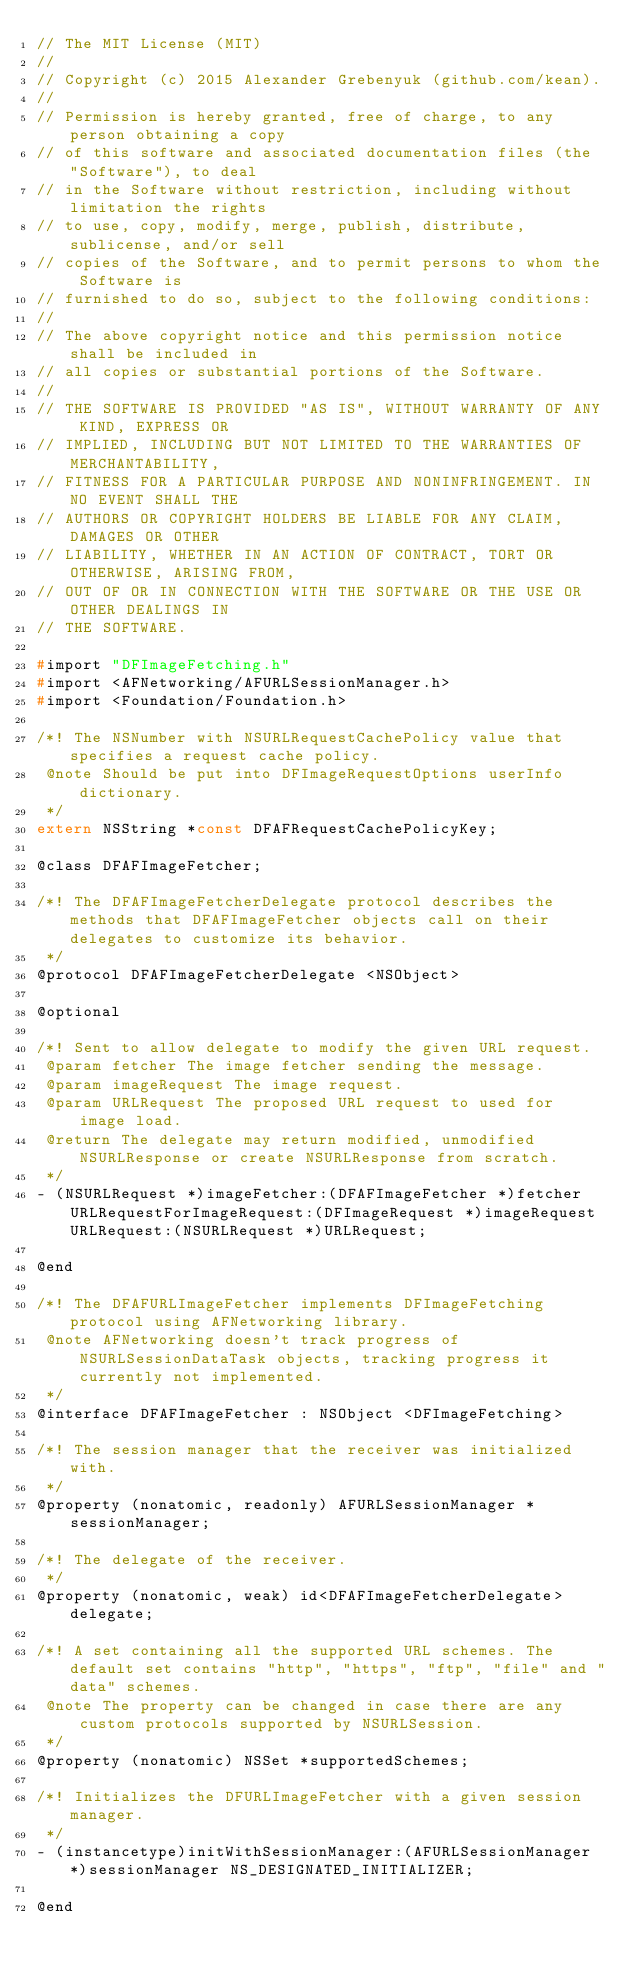Convert code to text. <code><loc_0><loc_0><loc_500><loc_500><_C_>// The MIT License (MIT)
//
// Copyright (c) 2015 Alexander Grebenyuk (github.com/kean).
//
// Permission is hereby granted, free of charge, to any person obtaining a copy
// of this software and associated documentation files (the "Software"), to deal
// in the Software without restriction, including without limitation the rights
// to use, copy, modify, merge, publish, distribute, sublicense, and/or sell
// copies of the Software, and to permit persons to whom the Software is
// furnished to do so, subject to the following conditions:
//
// The above copyright notice and this permission notice shall be included in
// all copies or substantial portions of the Software.
//
// THE SOFTWARE IS PROVIDED "AS IS", WITHOUT WARRANTY OF ANY KIND, EXPRESS OR
// IMPLIED, INCLUDING BUT NOT LIMITED TO THE WARRANTIES OF MERCHANTABILITY,
// FITNESS FOR A PARTICULAR PURPOSE AND NONINFRINGEMENT. IN NO EVENT SHALL THE
// AUTHORS OR COPYRIGHT HOLDERS BE LIABLE FOR ANY CLAIM, DAMAGES OR OTHER
// LIABILITY, WHETHER IN AN ACTION OF CONTRACT, TORT OR OTHERWISE, ARISING FROM,
// OUT OF OR IN CONNECTION WITH THE SOFTWARE OR THE USE OR OTHER DEALINGS IN
// THE SOFTWARE.

#import "DFImageFetching.h"
#import <AFNetworking/AFURLSessionManager.h>
#import <Foundation/Foundation.h>

/*! The NSNumber with NSURLRequestCachePolicy value that specifies a request cache policy.
 @note Should be put into DFImageRequestOptions userInfo dictionary.
 */
extern NSString *const DFAFRequestCachePolicyKey;

@class DFAFImageFetcher;

/*! The DFAFImageFetcherDelegate protocol describes the methods that DFAFImageFetcher objects call on their delegates to customize its behavior.
 */
@protocol DFAFImageFetcherDelegate <NSObject>

@optional

/*! Sent to allow delegate to modify the given URL request.
 @param fetcher The image fetcher sending the message.
 @param imageRequest The image request.
 @param URLRequest The proposed URL request to used for image load.
 @return The delegate may return modified, unmodified NSURLResponse or create NSURLResponse from scratch.
 */
- (NSURLRequest *)imageFetcher:(DFAFImageFetcher *)fetcher URLRequestForImageRequest:(DFImageRequest *)imageRequest URLRequest:(NSURLRequest *)URLRequest;

@end

/*! The DFAFURLImageFetcher implements DFImageFetching protocol using AFNetworking library.
 @note AFNetworking doesn't track progress of NSURLSessionDataTask objects, tracking progress it currently not implemented.
 */
@interface DFAFImageFetcher : NSObject <DFImageFetching>

/*! The session manager that the receiver was initialized with.
 */
@property (nonatomic, readonly) AFURLSessionManager *sessionManager;

/*! The delegate of the receiver.
 */
@property (nonatomic, weak) id<DFAFImageFetcherDelegate> delegate;

/*! A set containing all the supported URL schemes. The default set contains "http", "https", "ftp", "file" and "data" schemes.
 @note The property can be changed in case there are any custom protocols supported by NSURLSession.
 */
@property (nonatomic) NSSet *supportedSchemes;

/*! Initializes the DFURLImageFetcher with a given session manager.
 */
- (instancetype)initWithSessionManager:(AFURLSessionManager *)sessionManager NS_DESIGNATED_INITIALIZER;

@end
</code> 